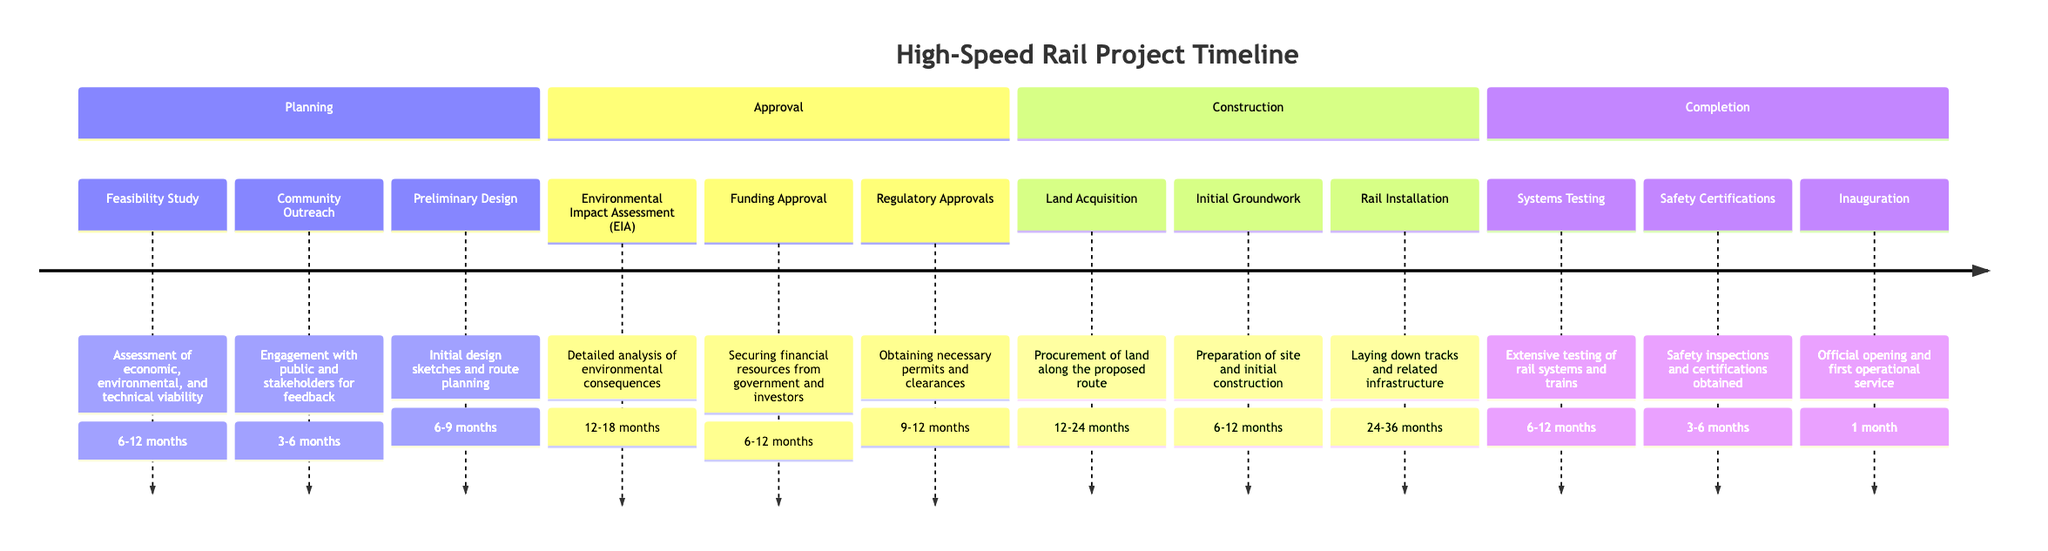What is the timeframe for the Feasibility Study? The diagram states that the Feasibility Study has a timeframe of 6 to 12 months. Therefore, I look at the "Planning" section and find the corresponding timeframe next to the Feasibility Study element.
Answer: 6-12 months How many elements are in the Approval phase? In the "Approval" phase, there are three elements listed: Environmental Impact Assessment, Funding Approval, and Regulatory Approvals. Simply count the items listed in this section to find the answer.
Answer: 3 What is the duration of the Rail Installation element? Rail Installation is listed in the "Construction" phase with a timeframe of 24 to 36 months. I locate this specific element in the diagram and check its corresponding timeframe.
Answer: 24-36 months What is the first element of the Completion phase? The first element in the "Completion" phase is Systems Testing. I can identify this by looking at the order of the elements listed within the Completion section.
Answer: Systems Testing Which phase has the longest individual timeframe? The "Construction" phase contains Rail Installation, which has the longest individual timeframe of 24 to 36 months. I compare the timeframes of all the elements in each phase and identify this as the maximum.
Answer: 24-36 months What is the total number of phases in the timeline? There are four distinct phases in the timeline: Planning, Approval, Construction, and Completion. By counting the phases listed at the top of the sections in the diagram, I reach the total.
Answer: 4 Which element in the Planning phase has the shortest duration? Community Outreach has the shortest duration of 3 to 6 months among the elements listed in the Planning phase. I scan through the timeframes of each element under Planning to determine the shortest.
Answer: 3-6 months How long does it take for Safety Certifications? Safety Certifications is listed in the Completion phase and has a timeframe of 3 to 6 months. I find the Safety Certifications element in the timeline and read its designated timeframe.
Answer: 3-6 months What is the last step in the high-speed rail project timeline? The last step listed in the timeline is Inauguration, which signifies the official opening and first operational service of the rail project. I identify this by checking the order of the elements in the Completion phase.
Answer: Inauguration 